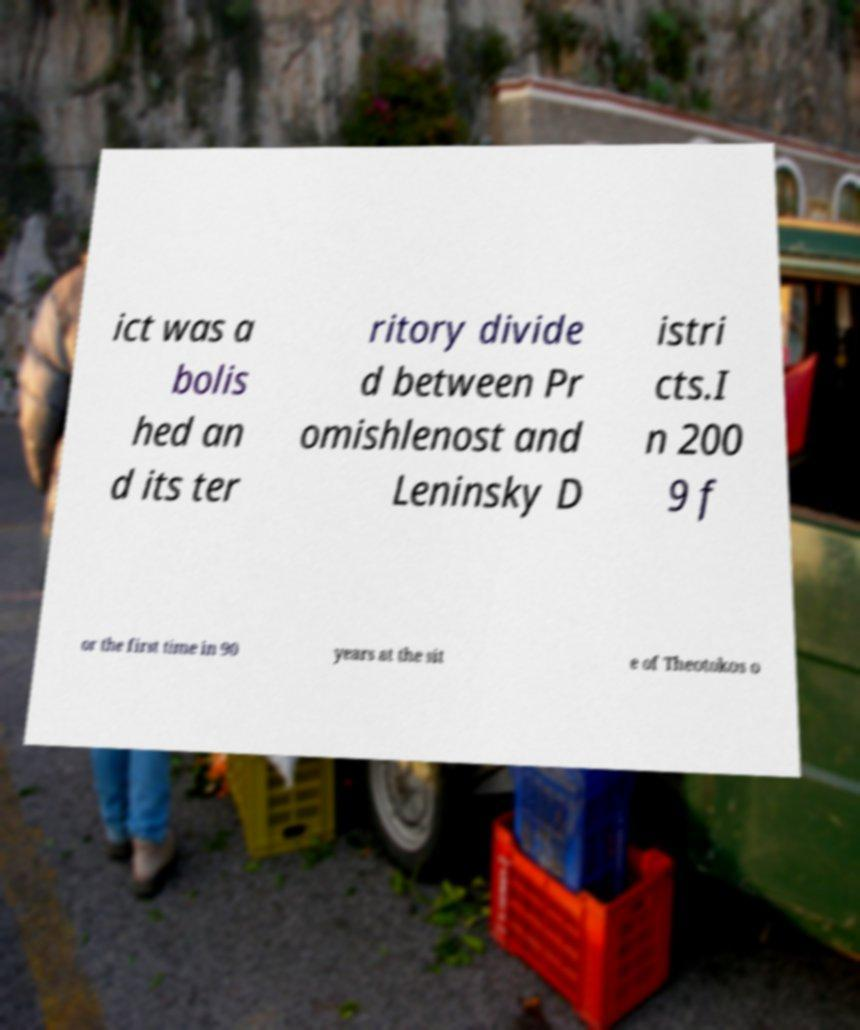Can you accurately transcribe the text from the provided image for me? ict was a bolis hed an d its ter ritory divide d between Pr omishlenost and Leninsky D istri cts.I n 200 9 f or the first time in 90 years at the sit e of Theotokos o 